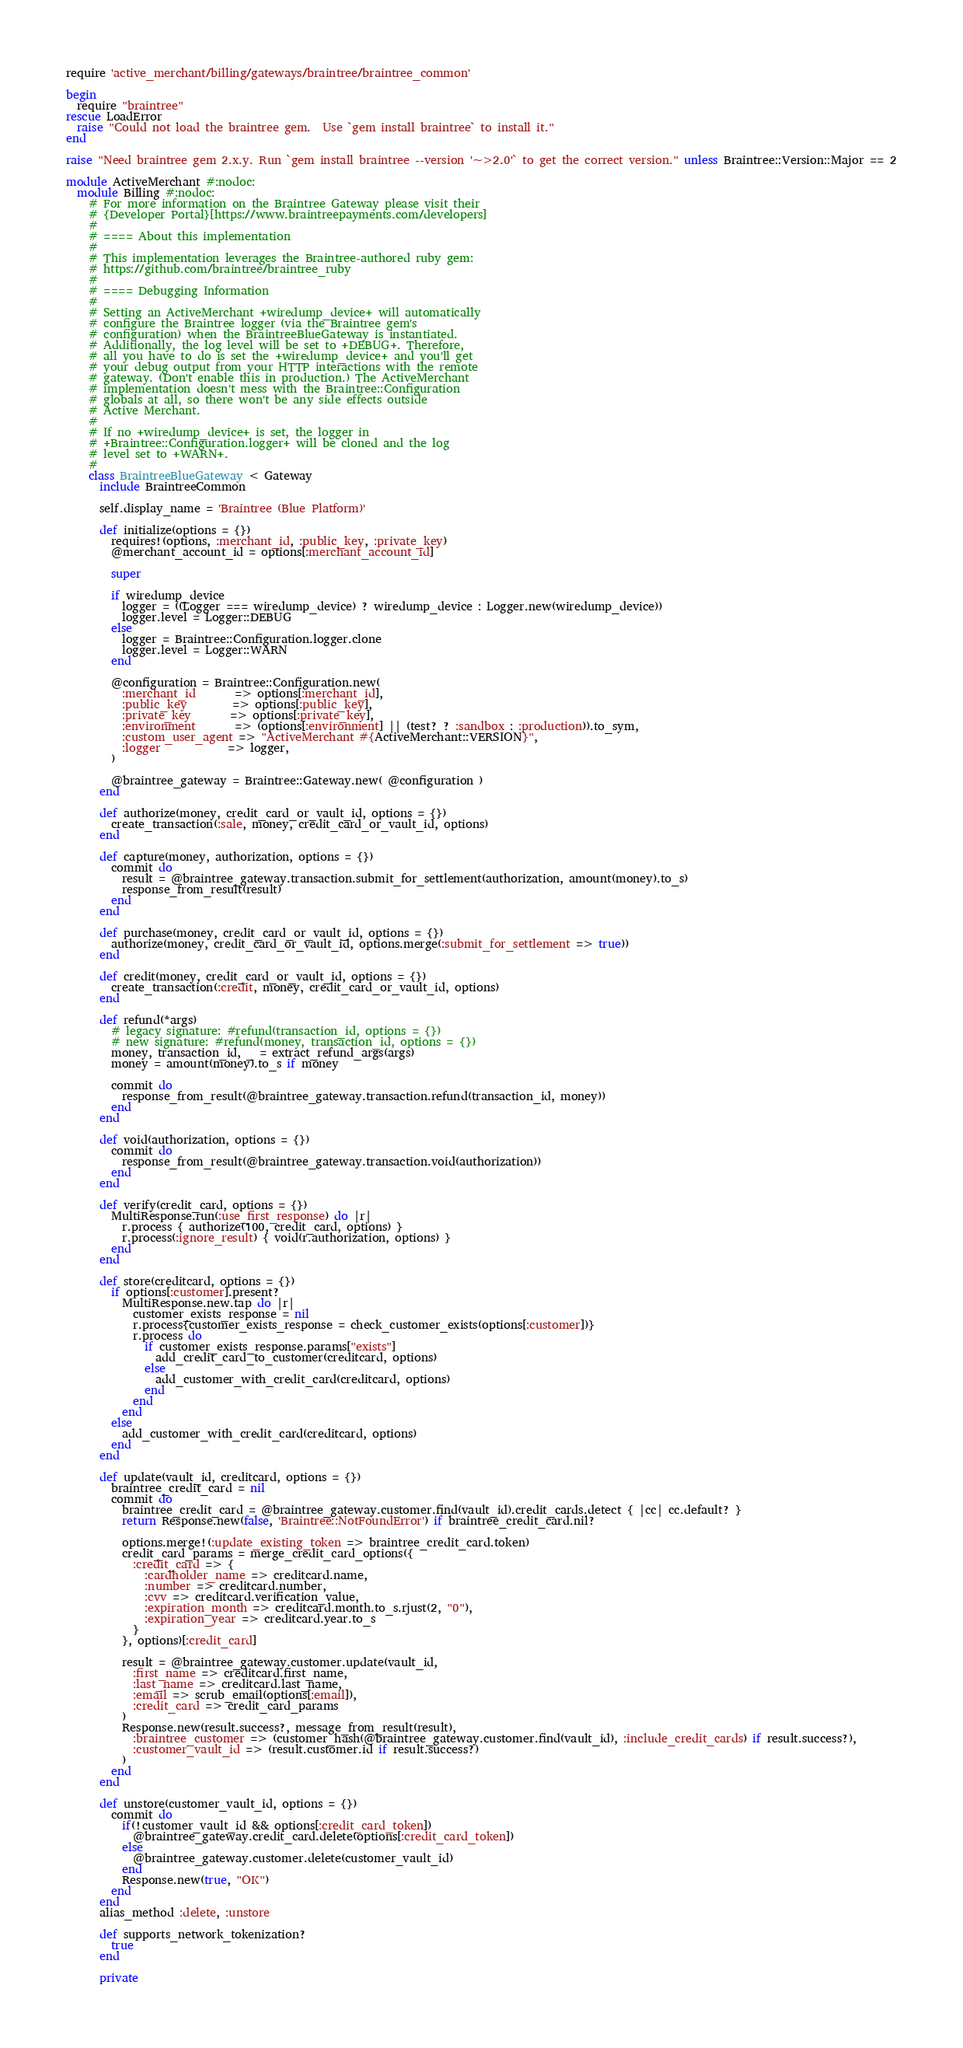<code> <loc_0><loc_0><loc_500><loc_500><_Ruby_>require 'active_merchant/billing/gateways/braintree/braintree_common'

begin
  require "braintree"
rescue LoadError
  raise "Could not load the braintree gem.  Use `gem install braintree` to install it."
end

raise "Need braintree gem 2.x.y. Run `gem install braintree --version '~>2.0'` to get the correct version." unless Braintree::Version::Major == 2

module ActiveMerchant #:nodoc:
  module Billing #:nodoc:
    # For more information on the Braintree Gateway please visit their
    # {Developer Portal}[https://www.braintreepayments.com/developers]
    #
    # ==== About this implementation
    #
    # This implementation leverages the Braintree-authored ruby gem:
    # https://github.com/braintree/braintree_ruby
    #
    # ==== Debugging Information
    #
    # Setting an ActiveMerchant +wiredump_device+ will automatically
    # configure the Braintree logger (via the Braintree gem's
    # configuration) when the BraintreeBlueGateway is instantiated.
    # Additionally, the log level will be set to +DEBUG+. Therefore,
    # all you have to do is set the +wiredump_device+ and you'll get
    # your debug output from your HTTP interactions with the remote
    # gateway. (Don't enable this in production.) The ActiveMerchant
    # implementation doesn't mess with the Braintree::Configuration
    # globals at all, so there won't be any side effects outside
    # Active Merchant.
    #
    # If no +wiredump_device+ is set, the logger in
    # +Braintree::Configuration.logger+ will be cloned and the log
    # level set to +WARN+.
    #
    class BraintreeBlueGateway < Gateway
      include BraintreeCommon

      self.display_name = 'Braintree (Blue Platform)'

      def initialize(options = {})
        requires!(options, :merchant_id, :public_key, :private_key)
        @merchant_account_id = options[:merchant_account_id]

        super

        if wiredump_device
          logger = ((Logger === wiredump_device) ? wiredump_device : Logger.new(wiredump_device))
          logger.level = Logger::DEBUG
        else
          logger = Braintree::Configuration.logger.clone
          logger.level = Logger::WARN
        end

        @configuration = Braintree::Configuration.new(
          :merchant_id       => options[:merchant_id],
          :public_key        => options[:public_key],
          :private_key       => options[:private_key],
          :environment       => (options[:environment] || (test? ? :sandbox : :production)).to_sym,
          :custom_user_agent => "ActiveMerchant #{ActiveMerchant::VERSION}",
          :logger            => logger,
        )

        @braintree_gateway = Braintree::Gateway.new( @configuration )
      end

      def authorize(money, credit_card_or_vault_id, options = {})
        create_transaction(:sale, money, credit_card_or_vault_id, options)
      end

      def capture(money, authorization, options = {})
        commit do
          result = @braintree_gateway.transaction.submit_for_settlement(authorization, amount(money).to_s)
          response_from_result(result)
        end
      end

      def purchase(money, credit_card_or_vault_id, options = {})
        authorize(money, credit_card_or_vault_id, options.merge(:submit_for_settlement => true))
      end

      def credit(money, credit_card_or_vault_id, options = {})
        create_transaction(:credit, money, credit_card_or_vault_id, options)
      end

      def refund(*args)
        # legacy signature: #refund(transaction_id, options = {})
        # new signature: #refund(money, transaction_id, options = {})
        money, transaction_id, _ = extract_refund_args(args)
        money = amount(money).to_s if money

        commit do
          response_from_result(@braintree_gateway.transaction.refund(transaction_id, money))
        end
      end

      def void(authorization, options = {})
        commit do
          response_from_result(@braintree_gateway.transaction.void(authorization))
        end
      end

      def verify(credit_card, options = {})
        MultiResponse.run(:use_first_response) do |r|
          r.process { authorize(100, credit_card, options) }
          r.process(:ignore_result) { void(r.authorization, options) }
        end
      end

      def store(creditcard, options = {})
        if options[:customer].present?
          MultiResponse.new.tap do |r|
            customer_exists_response = nil
            r.process{customer_exists_response = check_customer_exists(options[:customer])}
            r.process do
              if customer_exists_response.params["exists"]
                add_credit_card_to_customer(creditcard, options)
              else
                add_customer_with_credit_card(creditcard, options)
              end
            end
          end
        else
          add_customer_with_credit_card(creditcard, options)
        end
      end

      def update(vault_id, creditcard, options = {})
        braintree_credit_card = nil
        commit do
          braintree_credit_card = @braintree_gateway.customer.find(vault_id).credit_cards.detect { |cc| cc.default? }
          return Response.new(false, 'Braintree::NotFoundError') if braintree_credit_card.nil?

          options.merge!(:update_existing_token => braintree_credit_card.token)
          credit_card_params = merge_credit_card_options({
            :credit_card => {
              :cardholder_name => creditcard.name,
              :number => creditcard.number,
              :cvv => creditcard.verification_value,
              :expiration_month => creditcard.month.to_s.rjust(2, "0"),
              :expiration_year => creditcard.year.to_s
            }
          }, options)[:credit_card]

          result = @braintree_gateway.customer.update(vault_id,
            :first_name => creditcard.first_name,
            :last_name => creditcard.last_name,
            :email => scrub_email(options[:email]),
            :credit_card => credit_card_params
          )
          Response.new(result.success?, message_from_result(result),
            :braintree_customer => (customer_hash(@braintree_gateway.customer.find(vault_id), :include_credit_cards) if result.success?),
            :customer_vault_id => (result.customer.id if result.success?)
          )
        end
      end

      def unstore(customer_vault_id, options = {})
        commit do
          if(!customer_vault_id && options[:credit_card_token])
            @braintree_gateway.credit_card.delete(options[:credit_card_token])
          else
            @braintree_gateway.customer.delete(customer_vault_id)
          end
          Response.new(true, "OK")
        end
      end
      alias_method :delete, :unstore

      def supports_network_tokenization?
        true
      end

      private
</code> 